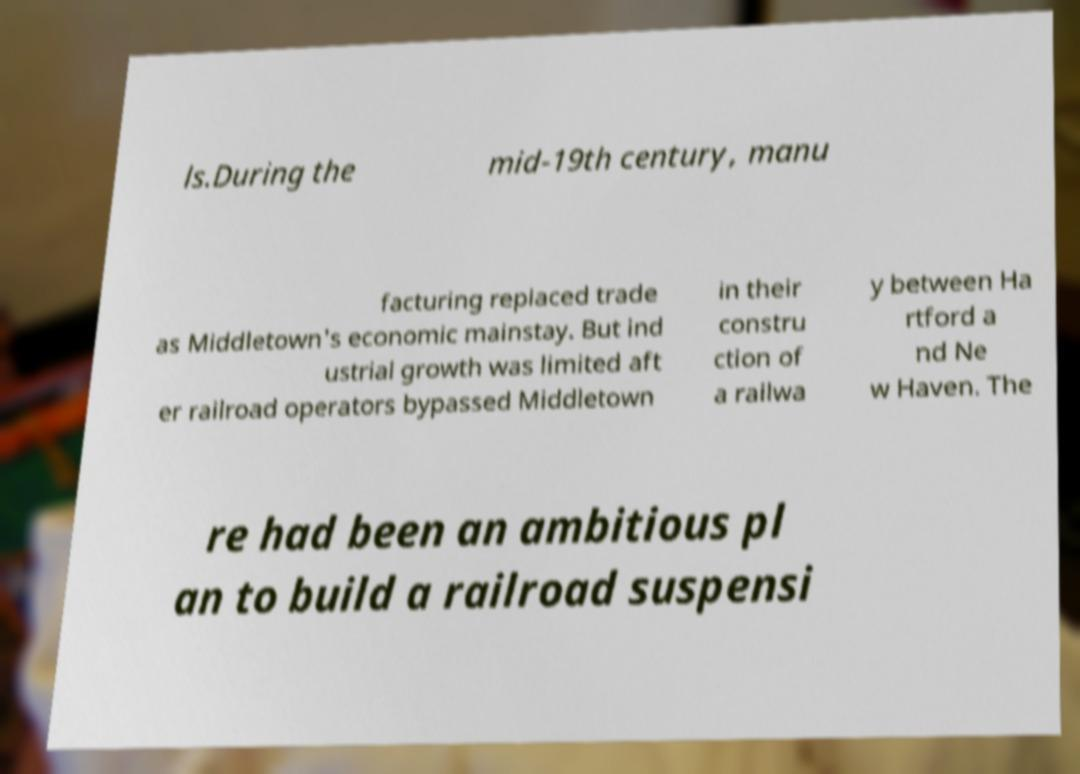What messages or text are displayed in this image? I need them in a readable, typed format. ls.During the mid-19th century, manu facturing replaced trade as Middletown's economic mainstay. But ind ustrial growth was limited aft er railroad operators bypassed Middletown in their constru ction of a railwa y between Ha rtford a nd Ne w Haven. The re had been an ambitious pl an to build a railroad suspensi 